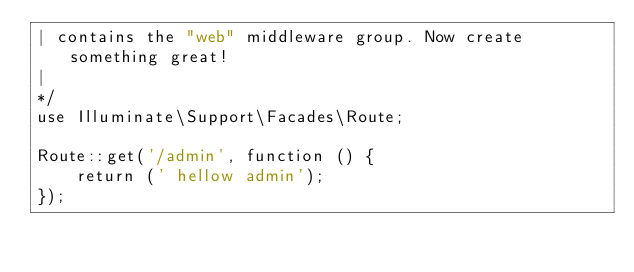Convert code to text. <code><loc_0><loc_0><loc_500><loc_500><_PHP_>| contains the "web" middleware group. Now create something great!
|
*/
use Illuminate\Support\Facades\Route;

Route::get('/admin', function () {
    return (' hellow admin');
});

</code> 